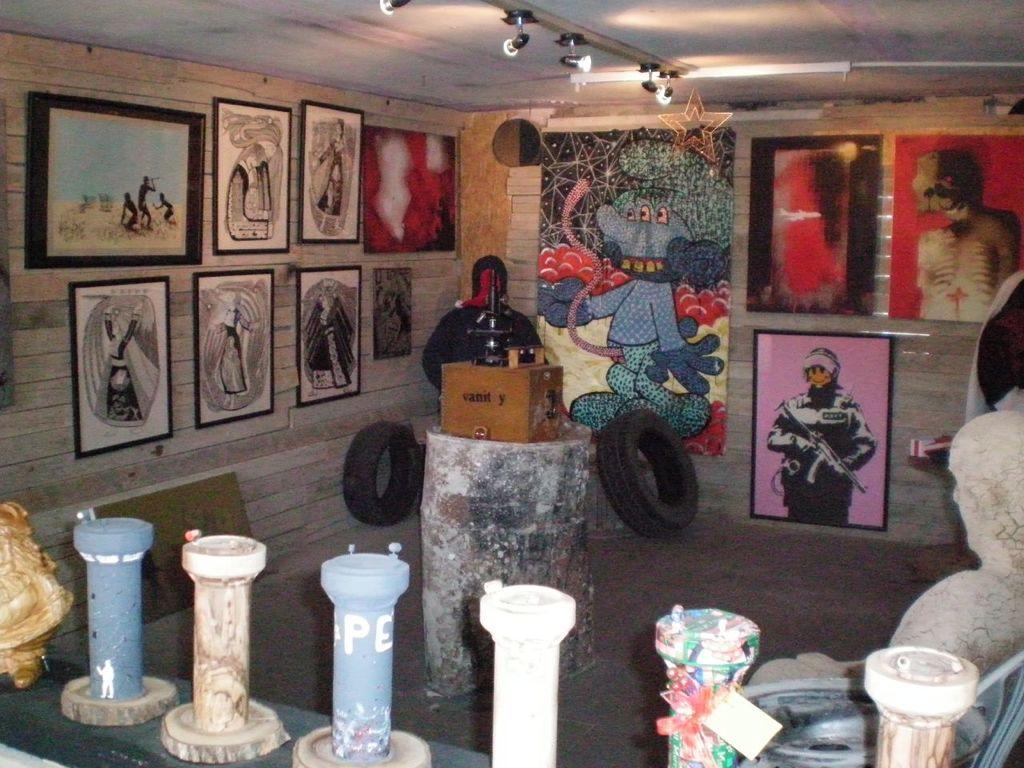Could you give a brief overview of what you see in this image? In this image I can see many frames and borders to the wall and these are colorful. In-front of the wall there are black color tires. In the front I can see some objects which are in blue and white color. 